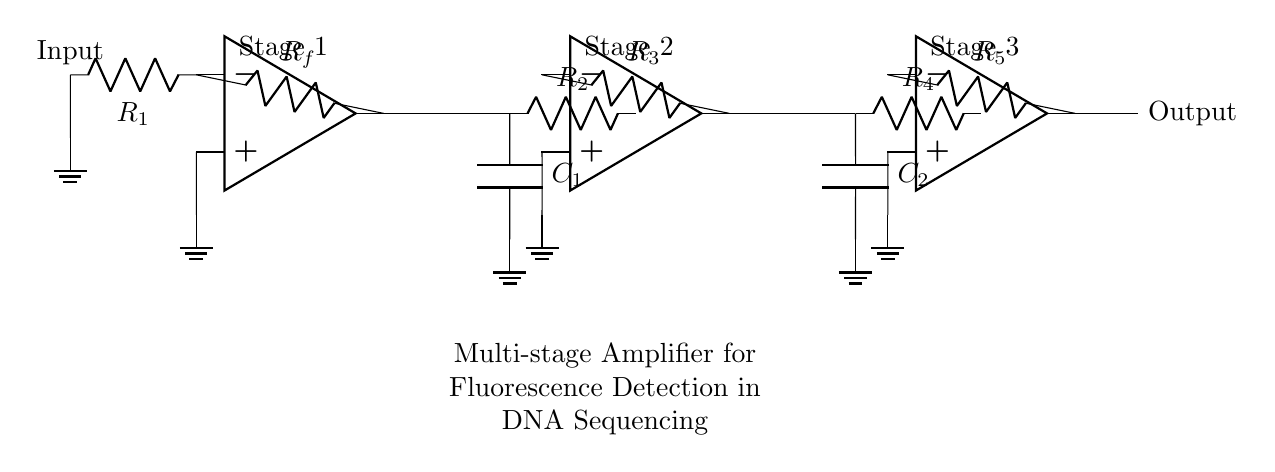What is the configuration of the amplifiers? The amplifiers are in a multi-stage configuration, meaning multiple amplifier stages are connected in sequence to amplify the signal progressively. Each stage builds on the output of the previous one to enhance the gain significantly.
Answer: Multi-stage What are the components used in the first stage? The first stage consists of an operational amplifier, a resistor labeled R1 connected to ground, and a feedback resistor labeled Rf connected from the output to the inverting input. This configuration allows for signal amplification.
Answer: Op amp, R1, Rf How many capacitors are in the circuit? There are two capacitors present in the circuit, each connected to the input of the respective second and third amplifier stages. Their purpose is generally to filter noise or provide stability in the amplification process.
Answer: Two Identify the output of the circuit. The output is taken from the last operational amplifier stage, which provides the amplified signal ready for further processing or measurement. This is crucial for detecting the fluorescence in DNA sequencing.
Answer: Output What is the purpose of resistors in this circuit? Resistors in this circuit control the gain of each amplifier stage and contribute to setting the input and feedback characteristics. Proper resistor values are essential for achieving the desired amplification and stability in operation.
Answer: Gain control How does the signal flow through the circuit? The signal flows from the input through the first amplifier stage, then to the second stage via the output of the first, and finally to the third stage. Each stage amplifies the signal before sending it to the next stage, culminating in the final output.
Answer: Sequentially 